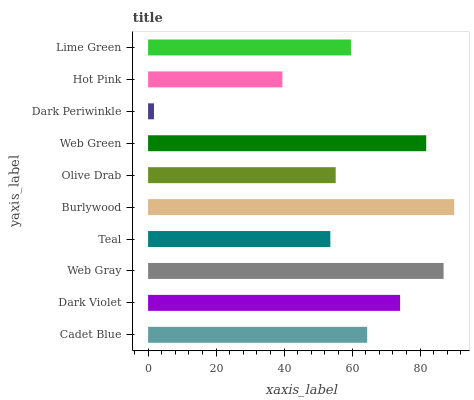Is Dark Periwinkle the minimum?
Answer yes or no. Yes. Is Burlywood the maximum?
Answer yes or no. Yes. Is Dark Violet the minimum?
Answer yes or no. No. Is Dark Violet the maximum?
Answer yes or no. No. Is Dark Violet greater than Cadet Blue?
Answer yes or no. Yes. Is Cadet Blue less than Dark Violet?
Answer yes or no. Yes. Is Cadet Blue greater than Dark Violet?
Answer yes or no. No. Is Dark Violet less than Cadet Blue?
Answer yes or no. No. Is Cadet Blue the high median?
Answer yes or no. Yes. Is Lime Green the low median?
Answer yes or no. Yes. Is Lime Green the high median?
Answer yes or no. No. Is Web Green the low median?
Answer yes or no. No. 